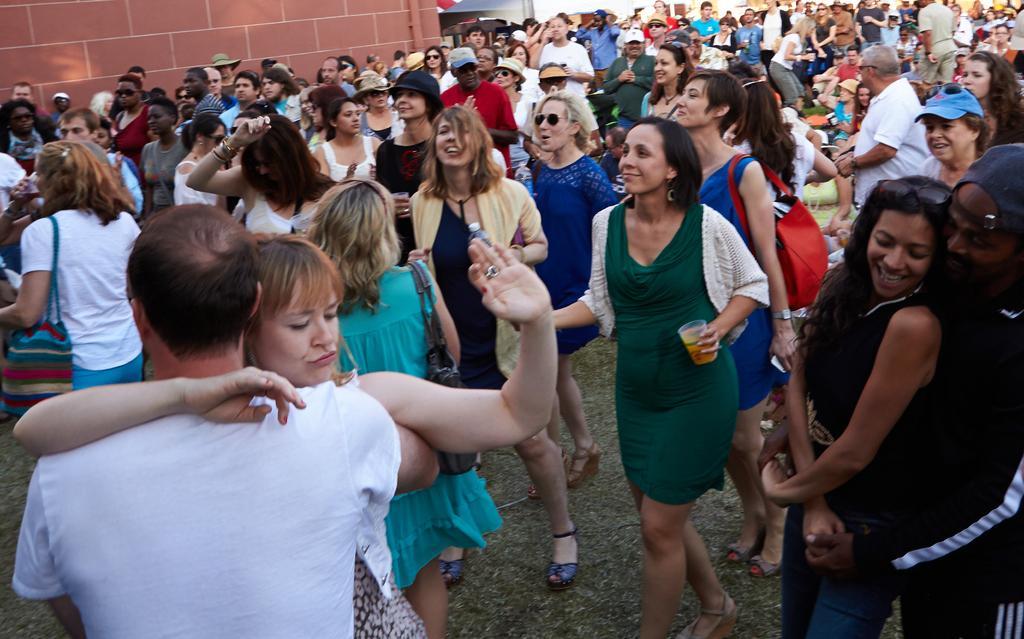Please provide a concise description of this image. In this image there are people doing different activities, in the background there is a wall. 